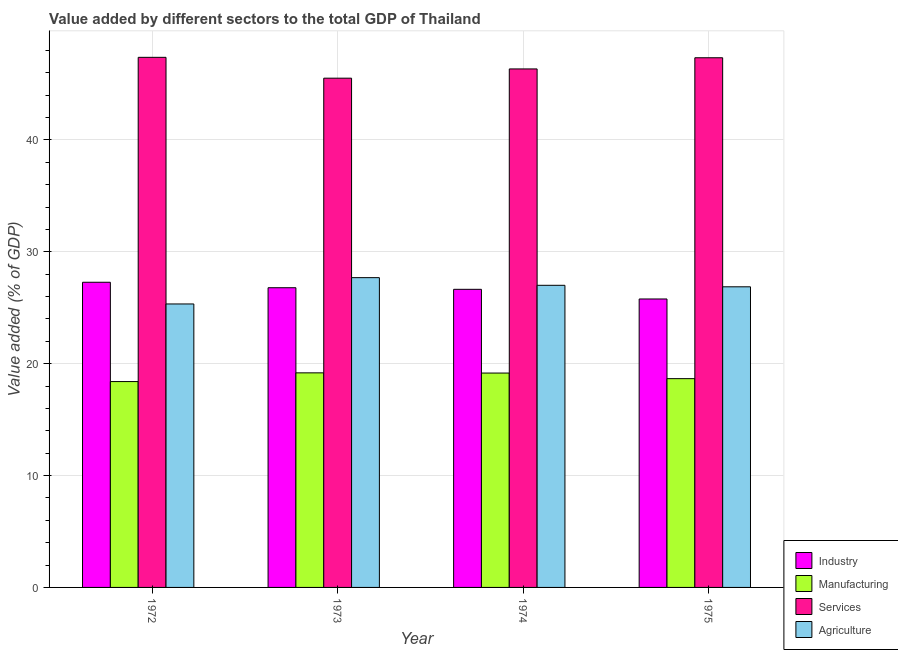How many different coloured bars are there?
Offer a very short reply. 4. How many bars are there on the 4th tick from the right?
Your response must be concise. 4. What is the label of the 4th group of bars from the left?
Offer a terse response. 1975. What is the value added by agricultural sector in 1974?
Keep it short and to the point. 27.01. Across all years, what is the maximum value added by agricultural sector?
Your answer should be very brief. 27.69. Across all years, what is the minimum value added by manufacturing sector?
Offer a very short reply. 18.4. In which year was the value added by agricultural sector minimum?
Keep it short and to the point. 1972. What is the total value added by agricultural sector in the graph?
Keep it short and to the point. 106.91. What is the difference between the value added by industrial sector in 1973 and that in 1975?
Ensure brevity in your answer.  1.01. What is the difference between the value added by agricultural sector in 1974 and the value added by industrial sector in 1972?
Provide a succinct answer. 1.67. What is the average value added by industrial sector per year?
Provide a short and direct response. 26.62. What is the ratio of the value added by industrial sector in 1972 to that in 1975?
Provide a succinct answer. 1.06. Is the value added by agricultural sector in 1972 less than that in 1975?
Your answer should be compact. Yes. What is the difference between the highest and the second highest value added by agricultural sector?
Make the answer very short. 0.68. What is the difference between the highest and the lowest value added by manufacturing sector?
Your response must be concise. 0.78. In how many years, is the value added by agricultural sector greater than the average value added by agricultural sector taken over all years?
Your answer should be compact. 3. Is the sum of the value added by industrial sector in 1974 and 1975 greater than the maximum value added by services sector across all years?
Your answer should be very brief. Yes. Is it the case that in every year, the sum of the value added by agricultural sector and value added by manufacturing sector is greater than the sum of value added by industrial sector and value added by services sector?
Keep it short and to the point. No. What does the 1st bar from the left in 1973 represents?
Make the answer very short. Industry. What does the 4th bar from the right in 1972 represents?
Provide a succinct answer. Industry. Are all the bars in the graph horizontal?
Provide a short and direct response. No. How many years are there in the graph?
Your answer should be very brief. 4. What is the difference between two consecutive major ticks on the Y-axis?
Provide a succinct answer. 10. Are the values on the major ticks of Y-axis written in scientific E-notation?
Your answer should be compact. No. Does the graph contain any zero values?
Give a very brief answer. No. How many legend labels are there?
Provide a short and direct response. 4. What is the title of the graph?
Offer a terse response. Value added by different sectors to the total GDP of Thailand. What is the label or title of the X-axis?
Your answer should be compact. Year. What is the label or title of the Y-axis?
Your response must be concise. Value added (% of GDP). What is the Value added (% of GDP) in Industry in 1972?
Make the answer very short. 27.28. What is the Value added (% of GDP) of Manufacturing in 1972?
Your answer should be compact. 18.4. What is the Value added (% of GDP) of Services in 1972?
Provide a succinct answer. 47.38. What is the Value added (% of GDP) of Agriculture in 1972?
Your answer should be very brief. 25.34. What is the Value added (% of GDP) in Industry in 1973?
Your answer should be very brief. 26.79. What is the Value added (% of GDP) in Manufacturing in 1973?
Your answer should be compact. 19.18. What is the Value added (% of GDP) of Services in 1973?
Your response must be concise. 45.52. What is the Value added (% of GDP) in Agriculture in 1973?
Your response must be concise. 27.69. What is the Value added (% of GDP) in Industry in 1974?
Your response must be concise. 26.65. What is the Value added (% of GDP) of Manufacturing in 1974?
Ensure brevity in your answer.  19.16. What is the Value added (% of GDP) of Services in 1974?
Keep it short and to the point. 46.35. What is the Value added (% of GDP) in Agriculture in 1974?
Your answer should be compact. 27.01. What is the Value added (% of GDP) in Industry in 1975?
Your answer should be compact. 25.78. What is the Value added (% of GDP) in Manufacturing in 1975?
Your response must be concise. 18.66. What is the Value added (% of GDP) of Services in 1975?
Ensure brevity in your answer.  47.35. What is the Value added (% of GDP) of Agriculture in 1975?
Offer a terse response. 26.87. Across all years, what is the maximum Value added (% of GDP) of Industry?
Ensure brevity in your answer.  27.28. Across all years, what is the maximum Value added (% of GDP) in Manufacturing?
Your answer should be very brief. 19.18. Across all years, what is the maximum Value added (% of GDP) in Services?
Give a very brief answer. 47.38. Across all years, what is the maximum Value added (% of GDP) in Agriculture?
Provide a succinct answer. 27.69. Across all years, what is the minimum Value added (% of GDP) in Industry?
Your answer should be very brief. 25.78. Across all years, what is the minimum Value added (% of GDP) of Manufacturing?
Provide a short and direct response. 18.4. Across all years, what is the minimum Value added (% of GDP) of Services?
Offer a terse response. 45.52. Across all years, what is the minimum Value added (% of GDP) in Agriculture?
Provide a succinct answer. 25.34. What is the total Value added (% of GDP) in Industry in the graph?
Give a very brief answer. 106.5. What is the total Value added (% of GDP) in Manufacturing in the graph?
Your response must be concise. 75.4. What is the total Value added (% of GDP) of Services in the graph?
Give a very brief answer. 186.6. What is the total Value added (% of GDP) of Agriculture in the graph?
Offer a very short reply. 106.91. What is the difference between the Value added (% of GDP) of Industry in 1972 and that in 1973?
Your answer should be very brief. 0.49. What is the difference between the Value added (% of GDP) of Manufacturing in 1972 and that in 1973?
Give a very brief answer. -0.78. What is the difference between the Value added (% of GDP) in Services in 1972 and that in 1973?
Ensure brevity in your answer.  1.86. What is the difference between the Value added (% of GDP) of Agriculture in 1972 and that in 1973?
Ensure brevity in your answer.  -2.35. What is the difference between the Value added (% of GDP) in Industry in 1972 and that in 1974?
Ensure brevity in your answer.  0.63. What is the difference between the Value added (% of GDP) in Manufacturing in 1972 and that in 1974?
Ensure brevity in your answer.  -0.76. What is the difference between the Value added (% of GDP) of Services in 1972 and that in 1974?
Offer a very short reply. 1.04. What is the difference between the Value added (% of GDP) in Agriculture in 1972 and that in 1974?
Give a very brief answer. -1.67. What is the difference between the Value added (% of GDP) of Industry in 1972 and that in 1975?
Offer a terse response. 1.5. What is the difference between the Value added (% of GDP) in Manufacturing in 1972 and that in 1975?
Give a very brief answer. -0.26. What is the difference between the Value added (% of GDP) of Services in 1972 and that in 1975?
Offer a very short reply. 0.04. What is the difference between the Value added (% of GDP) of Agriculture in 1972 and that in 1975?
Offer a terse response. -1.53. What is the difference between the Value added (% of GDP) in Industry in 1973 and that in 1974?
Your answer should be very brief. 0.14. What is the difference between the Value added (% of GDP) of Manufacturing in 1973 and that in 1974?
Your answer should be compact. 0.02. What is the difference between the Value added (% of GDP) in Services in 1973 and that in 1974?
Give a very brief answer. -0.83. What is the difference between the Value added (% of GDP) in Agriculture in 1973 and that in 1974?
Make the answer very short. 0.68. What is the difference between the Value added (% of GDP) of Manufacturing in 1973 and that in 1975?
Provide a succinct answer. 0.52. What is the difference between the Value added (% of GDP) in Services in 1973 and that in 1975?
Your answer should be very brief. -1.83. What is the difference between the Value added (% of GDP) in Agriculture in 1973 and that in 1975?
Ensure brevity in your answer.  0.82. What is the difference between the Value added (% of GDP) in Industry in 1974 and that in 1975?
Keep it short and to the point. 0.86. What is the difference between the Value added (% of GDP) of Manufacturing in 1974 and that in 1975?
Make the answer very short. 0.5. What is the difference between the Value added (% of GDP) in Services in 1974 and that in 1975?
Ensure brevity in your answer.  -1. What is the difference between the Value added (% of GDP) in Agriculture in 1974 and that in 1975?
Provide a succinct answer. 0.13. What is the difference between the Value added (% of GDP) of Industry in 1972 and the Value added (% of GDP) of Manufacturing in 1973?
Your answer should be very brief. 8.1. What is the difference between the Value added (% of GDP) in Industry in 1972 and the Value added (% of GDP) in Services in 1973?
Ensure brevity in your answer.  -18.24. What is the difference between the Value added (% of GDP) of Industry in 1972 and the Value added (% of GDP) of Agriculture in 1973?
Provide a short and direct response. -0.41. What is the difference between the Value added (% of GDP) in Manufacturing in 1972 and the Value added (% of GDP) in Services in 1973?
Keep it short and to the point. -27.12. What is the difference between the Value added (% of GDP) in Manufacturing in 1972 and the Value added (% of GDP) in Agriculture in 1973?
Offer a terse response. -9.29. What is the difference between the Value added (% of GDP) in Services in 1972 and the Value added (% of GDP) in Agriculture in 1973?
Provide a succinct answer. 19.69. What is the difference between the Value added (% of GDP) of Industry in 1972 and the Value added (% of GDP) of Manufacturing in 1974?
Your answer should be compact. 8.12. What is the difference between the Value added (% of GDP) of Industry in 1972 and the Value added (% of GDP) of Services in 1974?
Your answer should be very brief. -19.07. What is the difference between the Value added (% of GDP) in Industry in 1972 and the Value added (% of GDP) in Agriculture in 1974?
Provide a succinct answer. 0.27. What is the difference between the Value added (% of GDP) of Manufacturing in 1972 and the Value added (% of GDP) of Services in 1974?
Make the answer very short. -27.95. What is the difference between the Value added (% of GDP) of Manufacturing in 1972 and the Value added (% of GDP) of Agriculture in 1974?
Give a very brief answer. -8.6. What is the difference between the Value added (% of GDP) in Services in 1972 and the Value added (% of GDP) in Agriculture in 1974?
Keep it short and to the point. 20.38. What is the difference between the Value added (% of GDP) of Industry in 1972 and the Value added (% of GDP) of Manufacturing in 1975?
Offer a terse response. 8.62. What is the difference between the Value added (% of GDP) of Industry in 1972 and the Value added (% of GDP) of Services in 1975?
Provide a short and direct response. -20.07. What is the difference between the Value added (% of GDP) of Industry in 1972 and the Value added (% of GDP) of Agriculture in 1975?
Provide a short and direct response. 0.41. What is the difference between the Value added (% of GDP) in Manufacturing in 1972 and the Value added (% of GDP) in Services in 1975?
Offer a very short reply. -28.94. What is the difference between the Value added (% of GDP) in Manufacturing in 1972 and the Value added (% of GDP) in Agriculture in 1975?
Offer a very short reply. -8.47. What is the difference between the Value added (% of GDP) of Services in 1972 and the Value added (% of GDP) of Agriculture in 1975?
Provide a short and direct response. 20.51. What is the difference between the Value added (% of GDP) in Industry in 1973 and the Value added (% of GDP) in Manufacturing in 1974?
Give a very brief answer. 7.63. What is the difference between the Value added (% of GDP) of Industry in 1973 and the Value added (% of GDP) of Services in 1974?
Offer a terse response. -19.56. What is the difference between the Value added (% of GDP) in Industry in 1973 and the Value added (% of GDP) in Agriculture in 1974?
Keep it short and to the point. -0.22. What is the difference between the Value added (% of GDP) in Manufacturing in 1973 and the Value added (% of GDP) in Services in 1974?
Your answer should be compact. -27.17. What is the difference between the Value added (% of GDP) in Manufacturing in 1973 and the Value added (% of GDP) in Agriculture in 1974?
Your response must be concise. -7.83. What is the difference between the Value added (% of GDP) of Services in 1973 and the Value added (% of GDP) of Agriculture in 1974?
Offer a terse response. 18.51. What is the difference between the Value added (% of GDP) of Industry in 1973 and the Value added (% of GDP) of Manufacturing in 1975?
Give a very brief answer. 8.13. What is the difference between the Value added (% of GDP) of Industry in 1973 and the Value added (% of GDP) of Services in 1975?
Keep it short and to the point. -20.56. What is the difference between the Value added (% of GDP) in Industry in 1973 and the Value added (% of GDP) in Agriculture in 1975?
Offer a terse response. -0.08. What is the difference between the Value added (% of GDP) in Manufacturing in 1973 and the Value added (% of GDP) in Services in 1975?
Make the answer very short. -28.17. What is the difference between the Value added (% of GDP) in Manufacturing in 1973 and the Value added (% of GDP) in Agriculture in 1975?
Ensure brevity in your answer.  -7.69. What is the difference between the Value added (% of GDP) in Services in 1973 and the Value added (% of GDP) in Agriculture in 1975?
Offer a very short reply. 18.65. What is the difference between the Value added (% of GDP) in Industry in 1974 and the Value added (% of GDP) in Manufacturing in 1975?
Make the answer very short. 7.99. What is the difference between the Value added (% of GDP) in Industry in 1974 and the Value added (% of GDP) in Services in 1975?
Offer a very short reply. -20.7. What is the difference between the Value added (% of GDP) in Industry in 1974 and the Value added (% of GDP) in Agriculture in 1975?
Give a very brief answer. -0.22. What is the difference between the Value added (% of GDP) in Manufacturing in 1974 and the Value added (% of GDP) in Services in 1975?
Offer a very short reply. -28.18. What is the difference between the Value added (% of GDP) of Manufacturing in 1974 and the Value added (% of GDP) of Agriculture in 1975?
Provide a short and direct response. -7.71. What is the difference between the Value added (% of GDP) in Services in 1974 and the Value added (% of GDP) in Agriculture in 1975?
Your answer should be compact. 19.48. What is the average Value added (% of GDP) in Industry per year?
Your answer should be compact. 26.62. What is the average Value added (% of GDP) in Manufacturing per year?
Offer a very short reply. 18.85. What is the average Value added (% of GDP) of Services per year?
Your response must be concise. 46.65. What is the average Value added (% of GDP) in Agriculture per year?
Provide a succinct answer. 26.73. In the year 1972, what is the difference between the Value added (% of GDP) of Industry and Value added (% of GDP) of Manufacturing?
Give a very brief answer. 8.88. In the year 1972, what is the difference between the Value added (% of GDP) in Industry and Value added (% of GDP) in Services?
Your answer should be very brief. -20.11. In the year 1972, what is the difference between the Value added (% of GDP) in Industry and Value added (% of GDP) in Agriculture?
Give a very brief answer. 1.94. In the year 1972, what is the difference between the Value added (% of GDP) in Manufacturing and Value added (% of GDP) in Services?
Your response must be concise. -28.98. In the year 1972, what is the difference between the Value added (% of GDP) of Manufacturing and Value added (% of GDP) of Agriculture?
Ensure brevity in your answer.  -6.94. In the year 1972, what is the difference between the Value added (% of GDP) in Services and Value added (% of GDP) in Agriculture?
Offer a very short reply. 22.05. In the year 1973, what is the difference between the Value added (% of GDP) in Industry and Value added (% of GDP) in Manufacturing?
Make the answer very short. 7.61. In the year 1973, what is the difference between the Value added (% of GDP) in Industry and Value added (% of GDP) in Services?
Keep it short and to the point. -18.73. In the year 1973, what is the difference between the Value added (% of GDP) of Industry and Value added (% of GDP) of Agriculture?
Provide a succinct answer. -0.9. In the year 1973, what is the difference between the Value added (% of GDP) of Manufacturing and Value added (% of GDP) of Services?
Ensure brevity in your answer.  -26.34. In the year 1973, what is the difference between the Value added (% of GDP) in Manufacturing and Value added (% of GDP) in Agriculture?
Your answer should be very brief. -8.51. In the year 1973, what is the difference between the Value added (% of GDP) in Services and Value added (% of GDP) in Agriculture?
Offer a very short reply. 17.83. In the year 1974, what is the difference between the Value added (% of GDP) in Industry and Value added (% of GDP) in Manufacturing?
Give a very brief answer. 7.49. In the year 1974, what is the difference between the Value added (% of GDP) of Industry and Value added (% of GDP) of Services?
Your response must be concise. -19.7. In the year 1974, what is the difference between the Value added (% of GDP) of Industry and Value added (% of GDP) of Agriculture?
Give a very brief answer. -0.36. In the year 1974, what is the difference between the Value added (% of GDP) in Manufacturing and Value added (% of GDP) in Services?
Ensure brevity in your answer.  -27.18. In the year 1974, what is the difference between the Value added (% of GDP) of Manufacturing and Value added (% of GDP) of Agriculture?
Keep it short and to the point. -7.84. In the year 1974, what is the difference between the Value added (% of GDP) in Services and Value added (% of GDP) in Agriculture?
Your response must be concise. 19.34. In the year 1975, what is the difference between the Value added (% of GDP) of Industry and Value added (% of GDP) of Manufacturing?
Give a very brief answer. 7.12. In the year 1975, what is the difference between the Value added (% of GDP) in Industry and Value added (% of GDP) in Services?
Your response must be concise. -21.56. In the year 1975, what is the difference between the Value added (% of GDP) of Industry and Value added (% of GDP) of Agriculture?
Your answer should be compact. -1.09. In the year 1975, what is the difference between the Value added (% of GDP) of Manufacturing and Value added (% of GDP) of Services?
Your answer should be compact. -28.68. In the year 1975, what is the difference between the Value added (% of GDP) in Manufacturing and Value added (% of GDP) in Agriculture?
Give a very brief answer. -8.21. In the year 1975, what is the difference between the Value added (% of GDP) in Services and Value added (% of GDP) in Agriculture?
Keep it short and to the point. 20.47. What is the ratio of the Value added (% of GDP) in Industry in 1972 to that in 1973?
Make the answer very short. 1.02. What is the ratio of the Value added (% of GDP) of Manufacturing in 1972 to that in 1973?
Your response must be concise. 0.96. What is the ratio of the Value added (% of GDP) of Services in 1972 to that in 1973?
Make the answer very short. 1.04. What is the ratio of the Value added (% of GDP) of Agriculture in 1972 to that in 1973?
Provide a succinct answer. 0.92. What is the ratio of the Value added (% of GDP) in Industry in 1972 to that in 1974?
Provide a succinct answer. 1.02. What is the ratio of the Value added (% of GDP) in Manufacturing in 1972 to that in 1974?
Provide a succinct answer. 0.96. What is the ratio of the Value added (% of GDP) of Services in 1972 to that in 1974?
Provide a succinct answer. 1.02. What is the ratio of the Value added (% of GDP) in Agriculture in 1972 to that in 1974?
Your response must be concise. 0.94. What is the ratio of the Value added (% of GDP) of Industry in 1972 to that in 1975?
Offer a terse response. 1.06. What is the ratio of the Value added (% of GDP) of Manufacturing in 1972 to that in 1975?
Your answer should be very brief. 0.99. What is the ratio of the Value added (% of GDP) in Agriculture in 1972 to that in 1975?
Provide a short and direct response. 0.94. What is the ratio of the Value added (% of GDP) of Industry in 1973 to that in 1974?
Your answer should be very brief. 1.01. What is the ratio of the Value added (% of GDP) in Services in 1973 to that in 1974?
Your answer should be compact. 0.98. What is the ratio of the Value added (% of GDP) in Agriculture in 1973 to that in 1974?
Your answer should be compact. 1.03. What is the ratio of the Value added (% of GDP) of Industry in 1973 to that in 1975?
Make the answer very short. 1.04. What is the ratio of the Value added (% of GDP) of Manufacturing in 1973 to that in 1975?
Offer a very short reply. 1.03. What is the ratio of the Value added (% of GDP) of Services in 1973 to that in 1975?
Your answer should be very brief. 0.96. What is the ratio of the Value added (% of GDP) of Agriculture in 1973 to that in 1975?
Your answer should be very brief. 1.03. What is the ratio of the Value added (% of GDP) of Industry in 1974 to that in 1975?
Your answer should be very brief. 1.03. What is the ratio of the Value added (% of GDP) of Manufacturing in 1974 to that in 1975?
Provide a short and direct response. 1.03. What is the ratio of the Value added (% of GDP) in Services in 1974 to that in 1975?
Offer a very short reply. 0.98. What is the ratio of the Value added (% of GDP) in Agriculture in 1974 to that in 1975?
Provide a short and direct response. 1. What is the difference between the highest and the second highest Value added (% of GDP) of Industry?
Your answer should be compact. 0.49. What is the difference between the highest and the second highest Value added (% of GDP) in Manufacturing?
Your answer should be very brief. 0.02. What is the difference between the highest and the second highest Value added (% of GDP) in Services?
Offer a very short reply. 0.04. What is the difference between the highest and the second highest Value added (% of GDP) of Agriculture?
Your answer should be compact. 0.68. What is the difference between the highest and the lowest Value added (% of GDP) of Industry?
Offer a terse response. 1.5. What is the difference between the highest and the lowest Value added (% of GDP) in Manufacturing?
Provide a succinct answer. 0.78. What is the difference between the highest and the lowest Value added (% of GDP) of Services?
Offer a very short reply. 1.86. What is the difference between the highest and the lowest Value added (% of GDP) of Agriculture?
Offer a terse response. 2.35. 